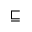<formula> <loc_0><loc_0><loc_500><loc_500>\sqsubseteq</formula> 